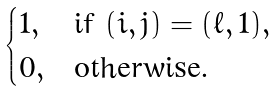<formula> <loc_0><loc_0><loc_500><loc_500>\begin{cases} 1 , & \text {if } ( i , j ) = ( \ell , 1 ) , \\ 0 , & \text {otherwise.} \end{cases}</formula> 